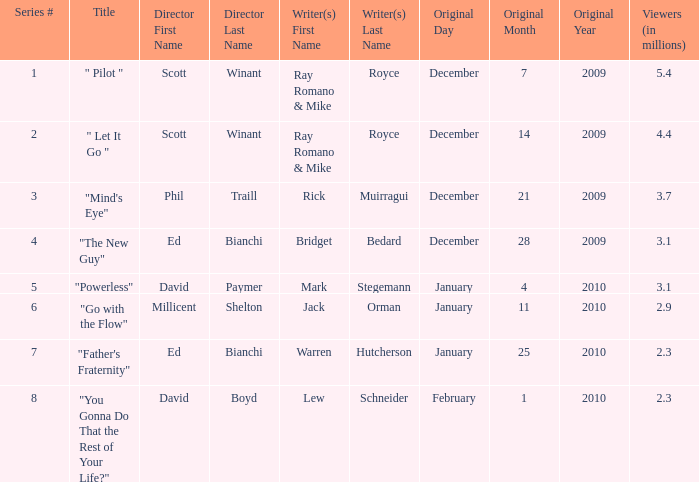What is the title of the episode written by Jack Orman? "Go with the Flow". Help me parse the entirety of this table. {'header': ['Series #', 'Title', 'Director First Name', 'Director Last Name', 'Writer(s) First Name', 'Writer(s) Last Name', 'Original Day', 'Original Month', 'Original Year', 'Viewers (in millions)'], 'rows': [['1', '" Pilot "', 'Scott', 'Winant', 'Ray Romano & Mike', 'Royce', 'December', '7', '2009', '5.4'], ['2', '" Let It Go "', 'Scott', 'Winant', 'Ray Romano & Mike', 'Royce', 'December', '14', '2009', '4.4'], ['3', '"Mind\'s Eye"', 'Phil', 'Traill', 'Rick', 'Muirragui', 'December', '21', '2009', '3.7'], ['4', '"The New Guy"', 'Ed', 'Bianchi', 'Bridget', 'Bedard', 'December', '28', '2009', '3.1'], ['5', '"Powerless"', 'David', 'Paymer', 'Mark', 'Stegemann', 'January', '4', '2010', '3.1'], ['6', '"Go with the Flow"', 'Millicent', 'Shelton', 'Jack', 'Orman', 'January', '11', '2010', '2.9'], ['7', '"Father\'s Fraternity"', 'Ed', 'Bianchi', 'Warren', 'Hutcherson', 'January', '25', '2010', '2.3'], ['8', '"You Gonna Do That the Rest of Your Life?"', 'David', 'Boyd', 'Lew', 'Schneider', 'February', '1', '2010', '2.3']]} 